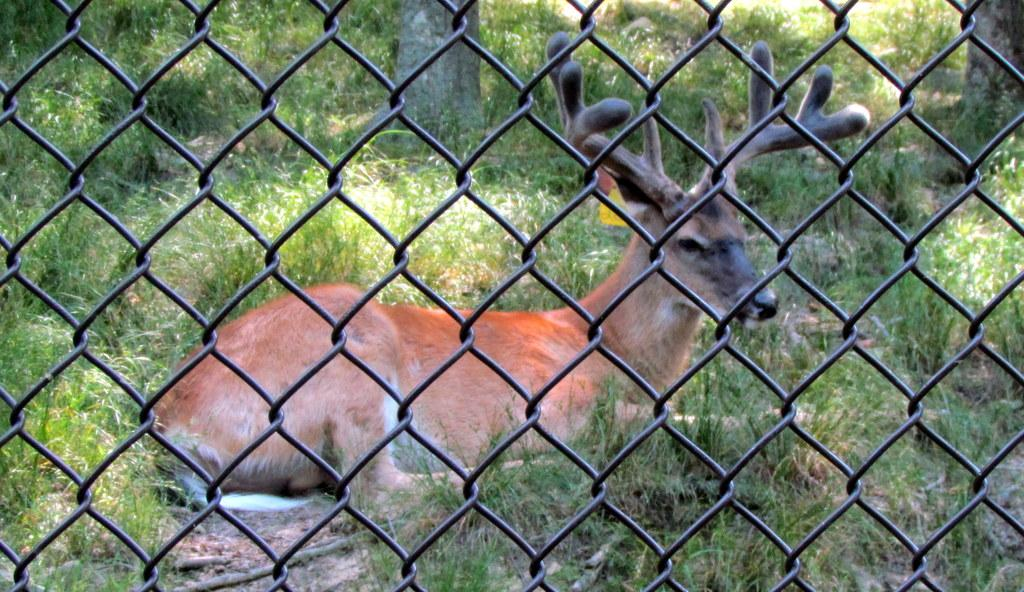What is the animal lying on the ground in the image? There is an animal lying on the ground in the image, but the specific type of animal is not mentioned in the facts. What is in front of the animal? There is a fencing in front of the animal. What type of vegetation is visible behind the animal? There is grass visible behind the animal. What can be seen in the background of the image? The trunks of trees are visible in the background of the image. Can you see the fireman putting out the fire with his toe in the image? There is no fireman or fire present in the image, so this scenario cannot be observed. 